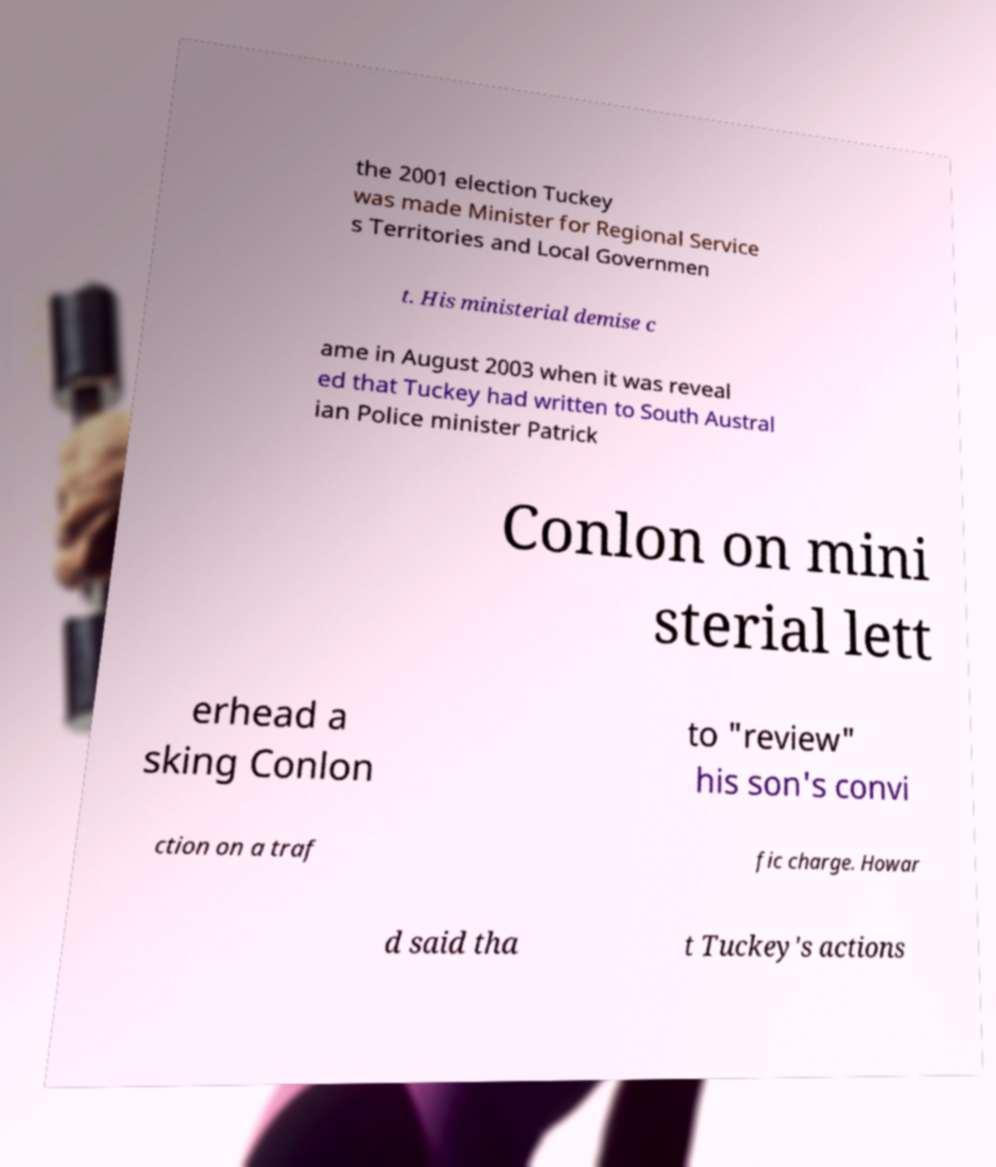There's text embedded in this image that I need extracted. Can you transcribe it verbatim? the 2001 election Tuckey was made Minister for Regional Service s Territories and Local Governmen t. His ministerial demise c ame in August 2003 when it was reveal ed that Tuckey had written to South Austral ian Police minister Patrick Conlon on mini sterial lett erhead a sking Conlon to "review" his son's convi ction on a traf fic charge. Howar d said tha t Tuckey's actions 